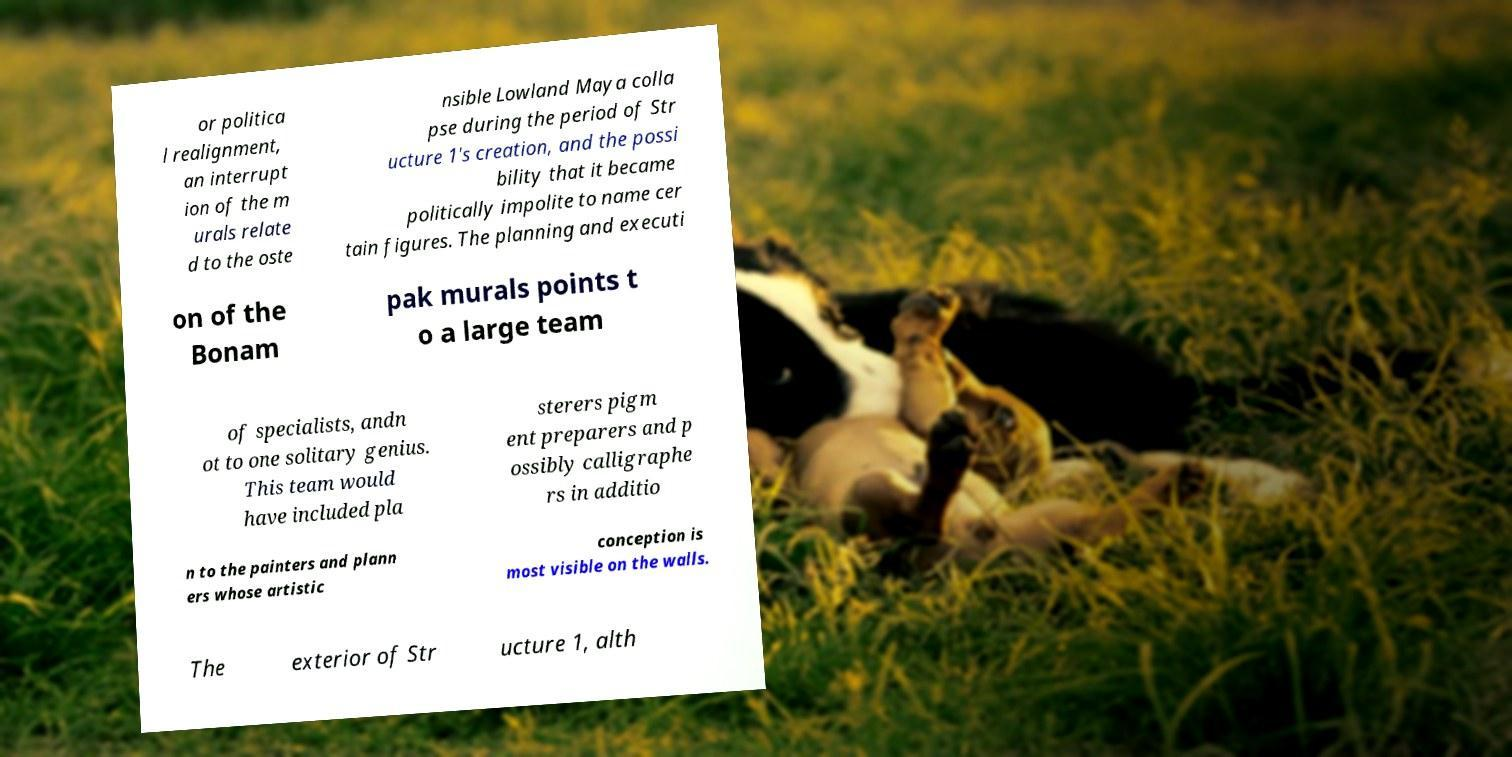Could you extract and type out the text from this image? or politica l realignment, an interrupt ion of the m urals relate d to the oste nsible Lowland Maya colla pse during the period of Str ucture 1's creation, and the possi bility that it became politically impolite to name cer tain figures. The planning and executi on of the Bonam pak murals points t o a large team of specialists, andn ot to one solitary genius. This team would have included pla sterers pigm ent preparers and p ossibly calligraphe rs in additio n to the painters and plann ers whose artistic conception is most visible on the walls. The exterior of Str ucture 1, alth 